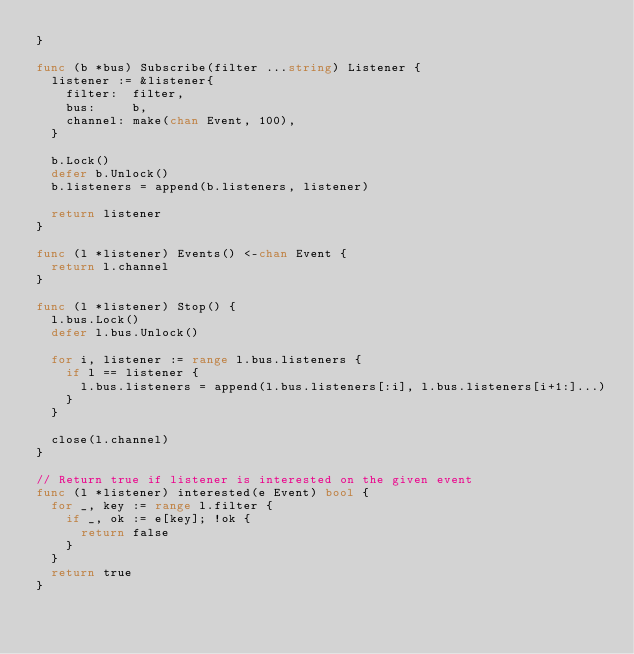<code> <loc_0><loc_0><loc_500><loc_500><_Go_>}

func (b *bus) Subscribe(filter ...string) Listener {
	listener := &listener{
		filter:  filter,
		bus:     b,
		channel: make(chan Event, 100),
	}

	b.Lock()
	defer b.Unlock()
	b.listeners = append(b.listeners, listener)

	return listener
}

func (l *listener) Events() <-chan Event {
	return l.channel
}

func (l *listener) Stop() {
	l.bus.Lock()
	defer l.bus.Unlock()

	for i, listener := range l.bus.listeners {
		if l == listener {
			l.bus.listeners = append(l.bus.listeners[:i], l.bus.listeners[i+1:]...)
		}
	}

	close(l.channel)
}

// Return true if listener is interested on the given event
func (l *listener) interested(e Event) bool {
	for _, key := range l.filter {
		if _, ok := e[key]; !ok {
			return false
		}
	}
	return true
}
</code> 